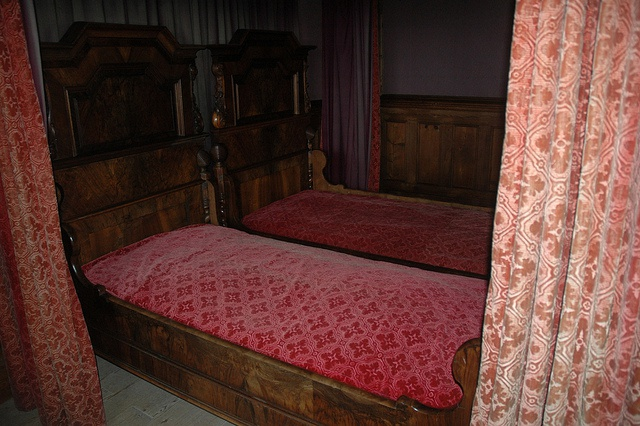Describe the objects in this image and their specific colors. I can see bed in black, maroon, and brown tones and bed in black, maroon, and gray tones in this image. 